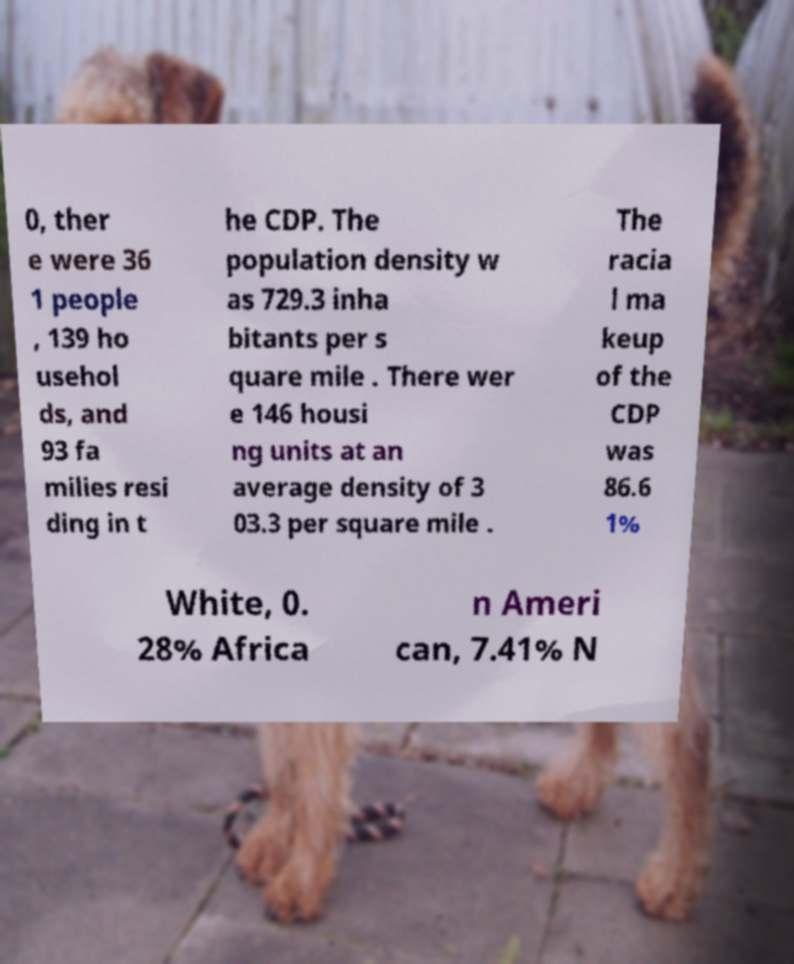Please read and relay the text visible in this image. What does it say? 0, ther e were 36 1 people , 139 ho usehol ds, and 93 fa milies resi ding in t he CDP. The population density w as 729.3 inha bitants per s quare mile . There wer e 146 housi ng units at an average density of 3 03.3 per square mile . The racia l ma keup of the CDP was 86.6 1% White, 0. 28% Africa n Ameri can, 7.41% N 